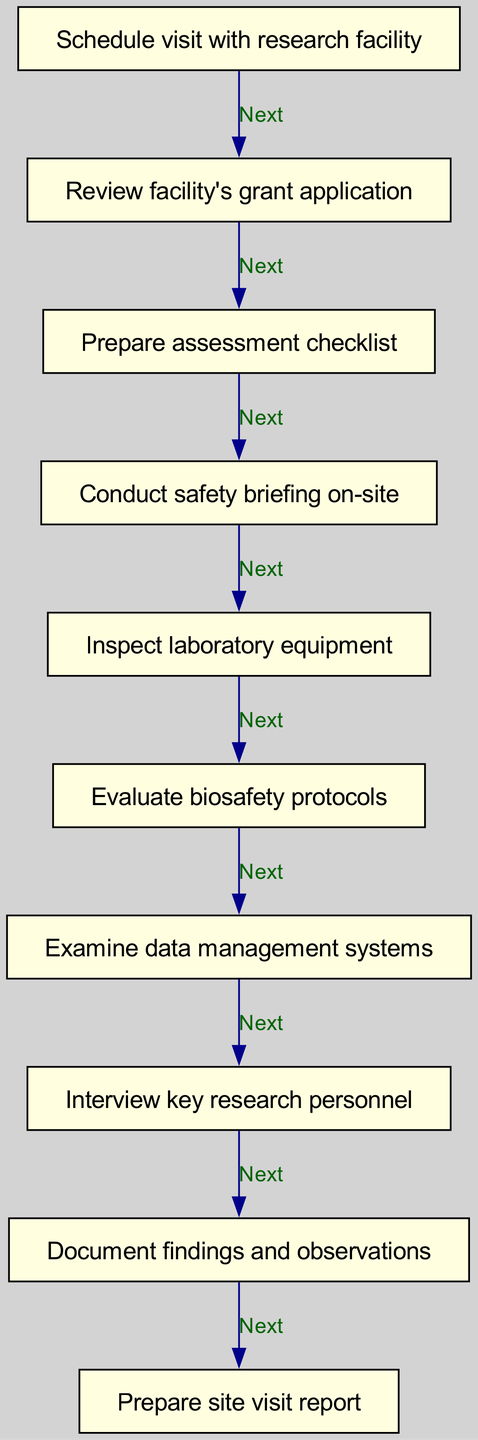What is the first step in the site visit process? The first node in the diagram indicates that the first step in the site visit process is to "Schedule visit with research facility."
Answer: Schedule visit with research facility How many steps are there in total? By counting all the nodes represented in the diagram, we find there are ten steps in total, from scheduling the visit to preparing the site visit report.
Answer: 10 What is the last step of the flow chart? The last node indicates that the final step in the process is to "Prepare site visit report," which comes after documenting findings and observations.
Answer: Prepare site visit report What action follows the safety briefing? After the action "Conduct safety briefing on-site," the next action in the flow chart is shown as "Inspect laboratory equipment."
Answer: Inspect laboratory equipment What type of personnel is interviewed after examining data systems? Following the node "Examine data management systems," the next step is to "Interview key research personnel," indicating that this is the type of personnel being interviewed.
Answer: Key research personnel How many connections exist between the steps? By analyzing the directed edges shown in the diagram, there are nine connections that link the steps in the process sequentially.
Answer: 9 What process step directly precedes evaluating biosafety protocols? The assessment step that comes immediately before "Evaluate biosafety protocols" is "Inspect laboratory equipment," as indicated by the arrows directing the flow.
Answer: Inspect laboratory equipment What is the purpose of preparing the assessment checklist? The preparation of the assessment checklist follows the review of the facility's grant application and serves as a guideline for the on-site assessment processes.
Answer: Guideline for assessment What safety aspect is addressed in the flow chart? The flow chart identifies that a "Conduct safety briefing on-site" is one of the steps, focusing on safety protocols prior to the facility inspection.
Answer: Safety protocols What occurs after documenting findings and observations? The diagram indicates that the action directly following "Document findings and observations" is "Prepare site visit report."
Answer: Prepare site visit report 